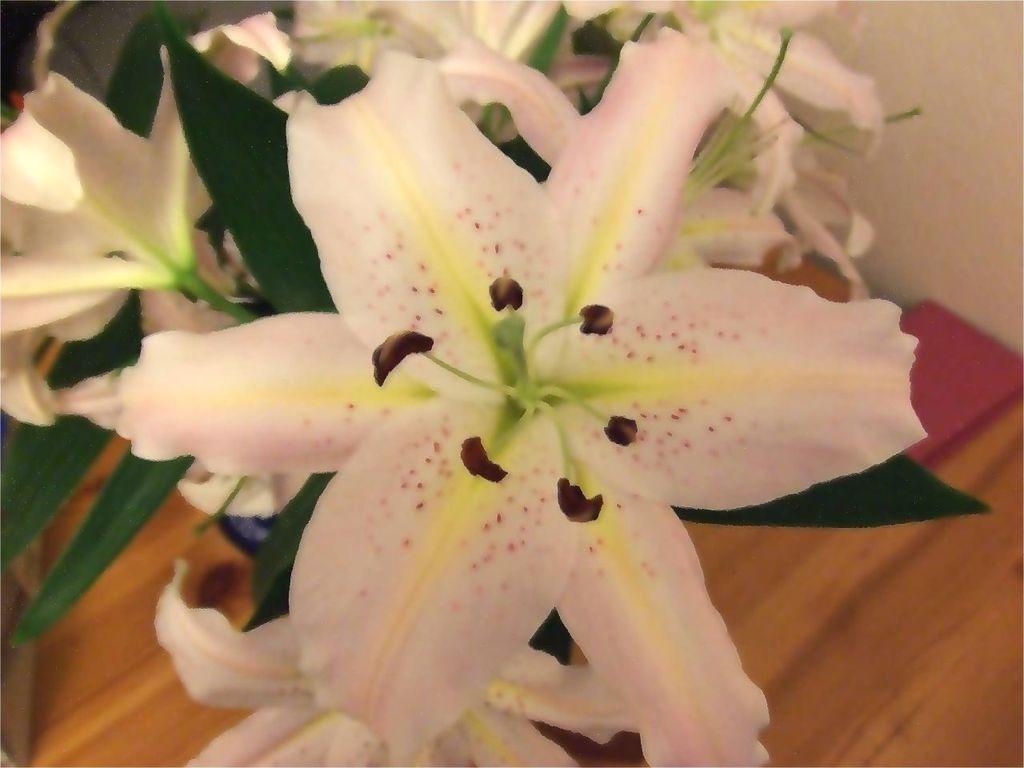Describe this image in one or two sentences. In this image we can see a few white colored flowers with leaves on a table. 